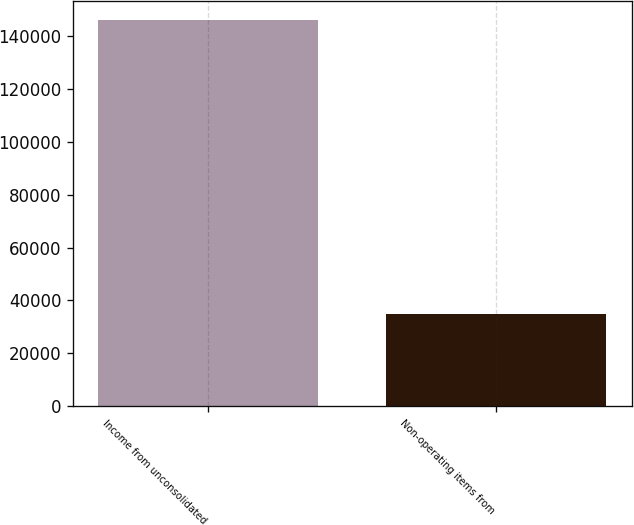<chart> <loc_0><loc_0><loc_500><loc_500><bar_chart><fcel>Income from unconsolidated<fcel>Non-operating items from<nl><fcel>145989<fcel>34751<nl></chart> 